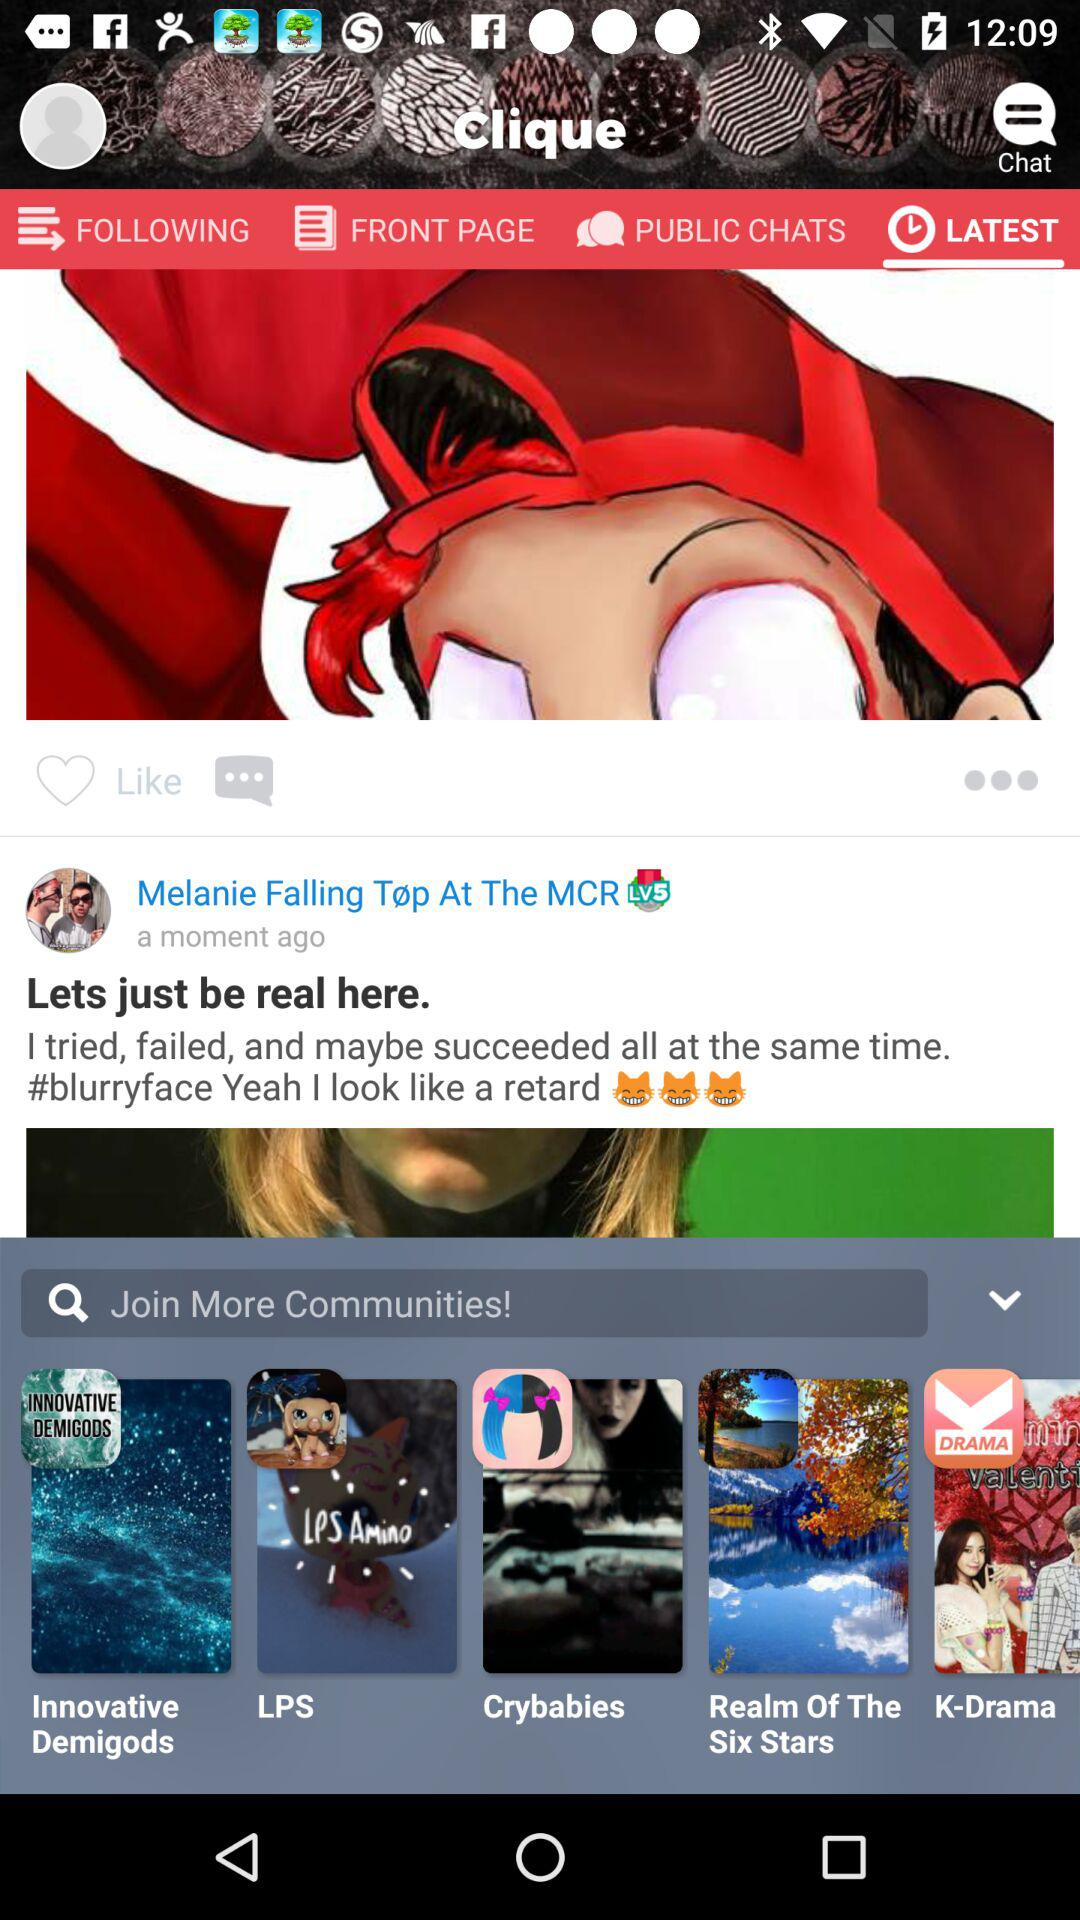What is the app name? The app name is "Clique". 